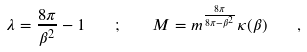<formula> <loc_0><loc_0><loc_500><loc_500>\lambda = \frac { 8 \pi } { \beta ^ { 2 } } - 1 \quad ; \quad M = m ^ { \frac { 8 \pi } { 8 \pi - \beta ^ { 2 } } } \kappa ( \beta ) \quad ,</formula> 